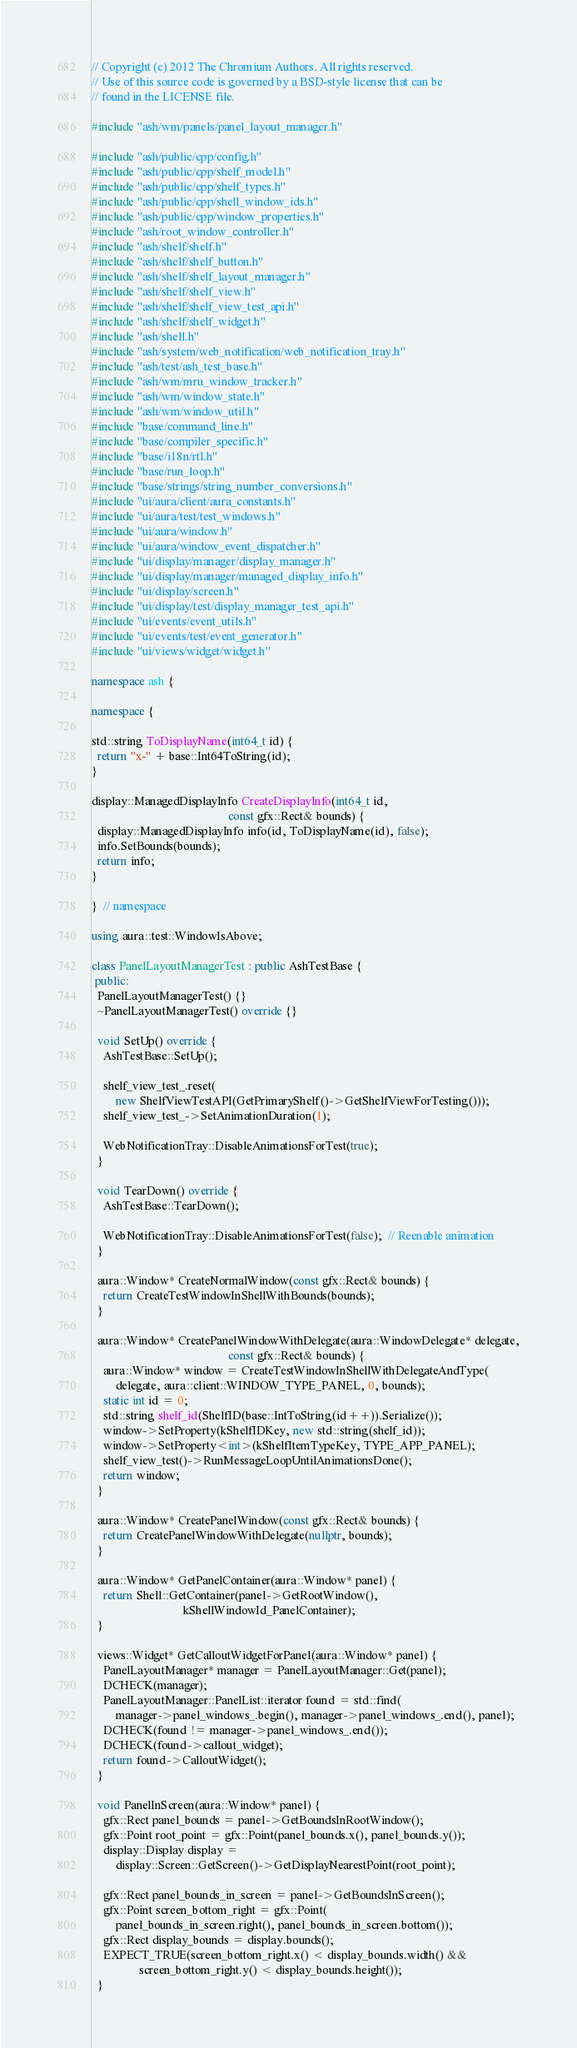Convert code to text. <code><loc_0><loc_0><loc_500><loc_500><_C++_>// Copyright (c) 2012 The Chromium Authors. All rights reserved.
// Use of this source code is governed by a BSD-style license that can be
// found in the LICENSE file.

#include "ash/wm/panels/panel_layout_manager.h"

#include "ash/public/cpp/config.h"
#include "ash/public/cpp/shelf_model.h"
#include "ash/public/cpp/shelf_types.h"
#include "ash/public/cpp/shell_window_ids.h"
#include "ash/public/cpp/window_properties.h"
#include "ash/root_window_controller.h"
#include "ash/shelf/shelf.h"
#include "ash/shelf/shelf_button.h"
#include "ash/shelf/shelf_layout_manager.h"
#include "ash/shelf/shelf_view.h"
#include "ash/shelf/shelf_view_test_api.h"
#include "ash/shelf/shelf_widget.h"
#include "ash/shell.h"
#include "ash/system/web_notification/web_notification_tray.h"
#include "ash/test/ash_test_base.h"
#include "ash/wm/mru_window_tracker.h"
#include "ash/wm/window_state.h"
#include "ash/wm/window_util.h"
#include "base/command_line.h"
#include "base/compiler_specific.h"
#include "base/i18n/rtl.h"
#include "base/run_loop.h"
#include "base/strings/string_number_conversions.h"
#include "ui/aura/client/aura_constants.h"
#include "ui/aura/test/test_windows.h"
#include "ui/aura/window.h"
#include "ui/aura/window_event_dispatcher.h"
#include "ui/display/manager/display_manager.h"
#include "ui/display/manager/managed_display_info.h"
#include "ui/display/screen.h"
#include "ui/display/test/display_manager_test_api.h"
#include "ui/events/event_utils.h"
#include "ui/events/test/event_generator.h"
#include "ui/views/widget/widget.h"

namespace ash {

namespace {

std::string ToDisplayName(int64_t id) {
  return "x-" + base::Int64ToString(id);
}

display::ManagedDisplayInfo CreateDisplayInfo(int64_t id,
                                              const gfx::Rect& bounds) {
  display::ManagedDisplayInfo info(id, ToDisplayName(id), false);
  info.SetBounds(bounds);
  return info;
}

}  // namespace

using aura::test::WindowIsAbove;

class PanelLayoutManagerTest : public AshTestBase {
 public:
  PanelLayoutManagerTest() {}
  ~PanelLayoutManagerTest() override {}

  void SetUp() override {
    AshTestBase::SetUp();

    shelf_view_test_.reset(
        new ShelfViewTestAPI(GetPrimaryShelf()->GetShelfViewForTesting()));
    shelf_view_test_->SetAnimationDuration(1);

    WebNotificationTray::DisableAnimationsForTest(true);
  }

  void TearDown() override {
    AshTestBase::TearDown();

    WebNotificationTray::DisableAnimationsForTest(false);  // Reenable animation
  }

  aura::Window* CreateNormalWindow(const gfx::Rect& bounds) {
    return CreateTestWindowInShellWithBounds(bounds);
  }

  aura::Window* CreatePanelWindowWithDelegate(aura::WindowDelegate* delegate,
                                              const gfx::Rect& bounds) {
    aura::Window* window = CreateTestWindowInShellWithDelegateAndType(
        delegate, aura::client::WINDOW_TYPE_PANEL, 0, bounds);
    static int id = 0;
    std::string shelf_id(ShelfID(base::IntToString(id++)).Serialize());
    window->SetProperty(kShelfIDKey, new std::string(shelf_id));
    window->SetProperty<int>(kShelfItemTypeKey, TYPE_APP_PANEL);
    shelf_view_test()->RunMessageLoopUntilAnimationsDone();
    return window;
  }

  aura::Window* CreatePanelWindow(const gfx::Rect& bounds) {
    return CreatePanelWindowWithDelegate(nullptr, bounds);
  }

  aura::Window* GetPanelContainer(aura::Window* panel) {
    return Shell::GetContainer(panel->GetRootWindow(),
                               kShellWindowId_PanelContainer);
  }

  views::Widget* GetCalloutWidgetForPanel(aura::Window* panel) {
    PanelLayoutManager* manager = PanelLayoutManager::Get(panel);
    DCHECK(manager);
    PanelLayoutManager::PanelList::iterator found = std::find(
        manager->panel_windows_.begin(), manager->panel_windows_.end(), panel);
    DCHECK(found != manager->panel_windows_.end());
    DCHECK(found->callout_widget);
    return found->CalloutWidget();
  }

  void PanelInScreen(aura::Window* panel) {
    gfx::Rect panel_bounds = panel->GetBoundsInRootWindow();
    gfx::Point root_point = gfx::Point(panel_bounds.x(), panel_bounds.y());
    display::Display display =
        display::Screen::GetScreen()->GetDisplayNearestPoint(root_point);

    gfx::Rect panel_bounds_in_screen = panel->GetBoundsInScreen();
    gfx::Point screen_bottom_right = gfx::Point(
        panel_bounds_in_screen.right(), panel_bounds_in_screen.bottom());
    gfx::Rect display_bounds = display.bounds();
    EXPECT_TRUE(screen_bottom_right.x() < display_bounds.width() &&
                screen_bottom_right.y() < display_bounds.height());
  }
</code> 